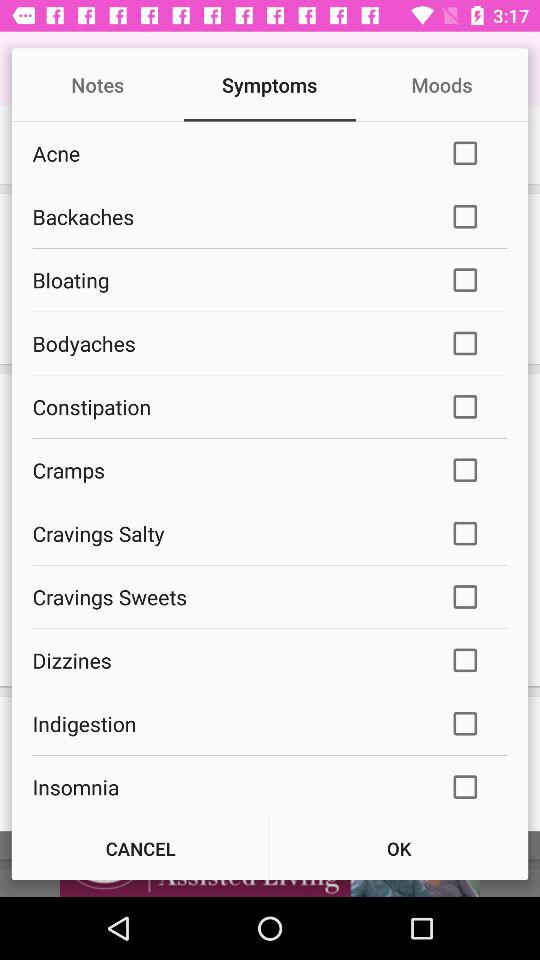Which option is selected? The selected option is "Symptoms". 